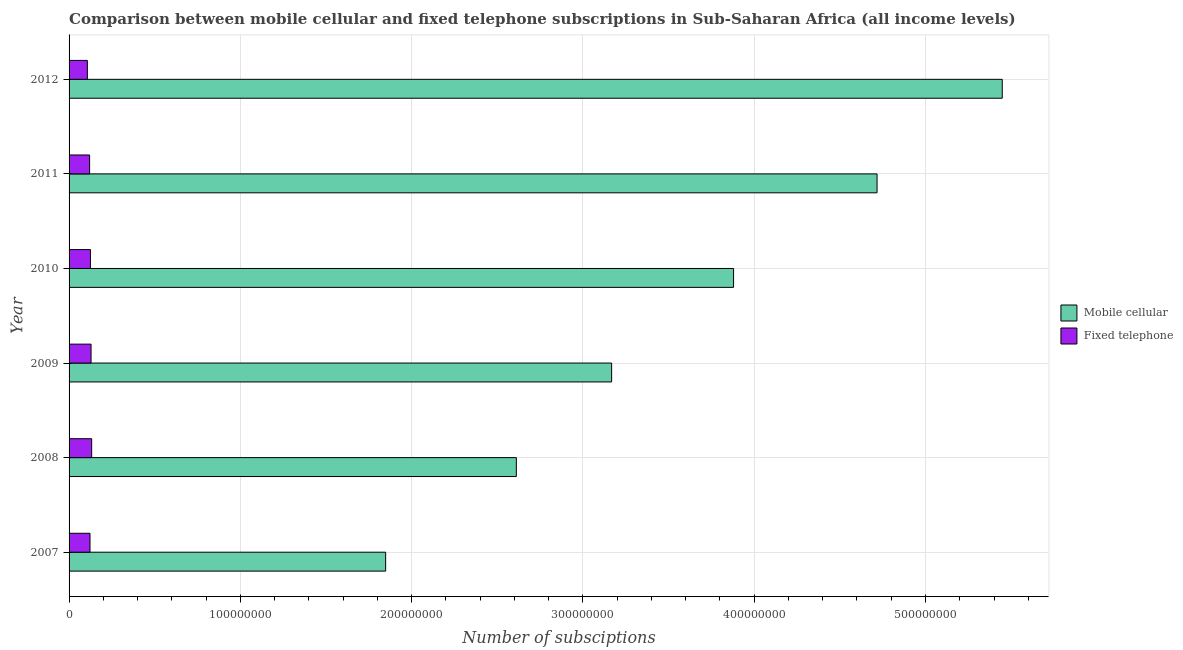How many different coloured bars are there?
Your response must be concise. 2. Are the number of bars per tick equal to the number of legend labels?
Provide a short and direct response. Yes. How many bars are there on the 1st tick from the bottom?
Your answer should be very brief. 2. What is the number of fixed telephone subscriptions in 2011?
Offer a terse response. 1.20e+07. Across all years, what is the maximum number of mobile cellular subscriptions?
Offer a very short reply. 5.45e+08. Across all years, what is the minimum number of fixed telephone subscriptions?
Your response must be concise. 1.07e+07. In which year was the number of fixed telephone subscriptions maximum?
Make the answer very short. 2008. What is the total number of fixed telephone subscriptions in the graph?
Give a very brief answer. 7.34e+07. What is the difference between the number of mobile cellular subscriptions in 2009 and that in 2011?
Your response must be concise. -1.55e+08. What is the difference between the number of fixed telephone subscriptions in 2011 and the number of mobile cellular subscriptions in 2012?
Give a very brief answer. -5.33e+08. What is the average number of mobile cellular subscriptions per year?
Make the answer very short. 3.61e+08. In the year 2010, what is the difference between the number of fixed telephone subscriptions and number of mobile cellular subscriptions?
Keep it short and to the point. -3.75e+08. In how many years, is the number of fixed telephone subscriptions greater than 220000000 ?
Offer a terse response. 0. What is the ratio of the number of fixed telephone subscriptions in 2007 to that in 2008?
Your response must be concise. 0.93. Is the number of mobile cellular subscriptions in 2007 less than that in 2008?
Provide a short and direct response. Yes. Is the difference between the number of mobile cellular subscriptions in 2007 and 2012 greater than the difference between the number of fixed telephone subscriptions in 2007 and 2012?
Keep it short and to the point. No. What is the difference between the highest and the second highest number of fixed telephone subscriptions?
Provide a succinct answer. 3.62e+05. What is the difference between the highest and the lowest number of mobile cellular subscriptions?
Your answer should be very brief. 3.60e+08. In how many years, is the number of fixed telephone subscriptions greater than the average number of fixed telephone subscriptions taken over all years?
Give a very brief answer. 3. Is the sum of the number of mobile cellular subscriptions in 2007 and 2009 greater than the maximum number of fixed telephone subscriptions across all years?
Keep it short and to the point. Yes. What does the 2nd bar from the top in 2009 represents?
Your answer should be compact. Mobile cellular. What does the 1st bar from the bottom in 2010 represents?
Your answer should be very brief. Mobile cellular. How many years are there in the graph?
Offer a terse response. 6. Does the graph contain grids?
Keep it short and to the point. Yes. How many legend labels are there?
Your answer should be compact. 2. What is the title of the graph?
Offer a very short reply. Comparison between mobile cellular and fixed telephone subscriptions in Sub-Saharan Africa (all income levels). What is the label or title of the X-axis?
Provide a succinct answer. Number of subsciptions. What is the label or title of the Y-axis?
Offer a terse response. Year. What is the Number of subsciptions in Mobile cellular in 2007?
Offer a very short reply. 1.85e+08. What is the Number of subsciptions in Fixed telephone in 2007?
Make the answer very short. 1.22e+07. What is the Number of subsciptions in Mobile cellular in 2008?
Provide a short and direct response. 2.61e+08. What is the Number of subsciptions in Fixed telephone in 2008?
Your response must be concise. 1.32e+07. What is the Number of subsciptions of Mobile cellular in 2009?
Make the answer very short. 3.17e+08. What is the Number of subsciptions of Fixed telephone in 2009?
Offer a terse response. 1.28e+07. What is the Number of subsciptions of Mobile cellular in 2010?
Keep it short and to the point. 3.88e+08. What is the Number of subsciptions of Fixed telephone in 2010?
Ensure brevity in your answer.  1.25e+07. What is the Number of subsciptions of Mobile cellular in 2011?
Ensure brevity in your answer.  4.72e+08. What is the Number of subsciptions in Fixed telephone in 2011?
Provide a short and direct response. 1.20e+07. What is the Number of subsciptions in Mobile cellular in 2012?
Your response must be concise. 5.45e+08. What is the Number of subsciptions in Fixed telephone in 2012?
Your answer should be compact. 1.07e+07. Across all years, what is the maximum Number of subsciptions in Mobile cellular?
Your response must be concise. 5.45e+08. Across all years, what is the maximum Number of subsciptions of Fixed telephone?
Ensure brevity in your answer.  1.32e+07. Across all years, what is the minimum Number of subsciptions of Mobile cellular?
Provide a short and direct response. 1.85e+08. Across all years, what is the minimum Number of subsciptions in Fixed telephone?
Make the answer very short. 1.07e+07. What is the total Number of subsciptions in Mobile cellular in the graph?
Keep it short and to the point. 2.17e+09. What is the total Number of subsciptions in Fixed telephone in the graph?
Offer a very short reply. 7.34e+07. What is the difference between the Number of subsciptions in Mobile cellular in 2007 and that in 2008?
Offer a terse response. -7.63e+07. What is the difference between the Number of subsciptions of Fixed telephone in 2007 and that in 2008?
Provide a succinct answer. -9.74e+05. What is the difference between the Number of subsciptions in Mobile cellular in 2007 and that in 2009?
Offer a very short reply. -1.32e+08. What is the difference between the Number of subsciptions in Fixed telephone in 2007 and that in 2009?
Your response must be concise. -6.12e+05. What is the difference between the Number of subsciptions in Mobile cellular in 2007 and that in 2010?
Ensure brevity in your answer.  -2.03e+08. What is the difference between the Number of subsciptions in Fixed telephone in 2007 and that in 2010?
Keep it short and to the point. -2.62e+05. What is the difference between the Number of subsciptions in Mobile cellular in 2007 and that in 2011?
Provide a succinct answer. -2.87e+08. What is the difference between the Number of subsciptions in Fixed telephone in 2007 and that in 2011?
Ensure brevity in your answer.  2.26e+05. What is the difference between the Number of subsciptions in Mobile cellular in 2007 and that in 2012?
Ensure brevity in your answer.  -3.60e+08. What is the difference between the Number of subsciptions of Fixed telephone in 2007 and that in 2012?
Provide a short and direct response. 1.54e+06. What is the difference between the Number of subsciptions of Mobile cellular in 2008 and that in 2009?
Provide a short and direct response. -5.56e+07. What is the difference between the Number of subsciptions in Fixed telephone in 2008 and that in 2009?
Keep it short and to the point. 3.62e+05. What is the difference between the Number of subsciptions of Mobile cellular in 2008 and that in 2010?
Your response must be concise. -1.27e+08. What is the difference between the Number of subsciptions of Fixed telephone in 2008 and that in 2010?
Make the answer very short. 7.12e+05. What is the difference between the Number of subsciptions in Mobile cellular in 2008 and that in 2011?
Offer a very short reply. -2.11e+08. What is the difference between the Number of subsciptions of Fixed telephone in 2008 and that in 2011?
Provide a succinct answer. 1.20e+06. What is the difference between the Number of subsciptions in Mobile cellular in 2008 and that in 2012?
Ensure brevity in your answer.  -2.84e+08. What is the difference between the Number of subsciptions of Fixed telephone in 2008 and that in 2012?
Offer a very short reply. 2.51e+06. What is the difference between the Number of subsciptions of Mobile cellular in 2009 and that in 2010?
Make the answer very short. -7.12e+07. What is the difference between the Number of subsciptions of Fixed telephone in 2009 and that in 2010?
Your answer should be very brief. 3.50e+05. What is the difference between the Number of subsciptions of Mobile cellular in 2009 and that in 2011?
Provide a succinct answer. -1.55e+08. What is the difference between the Number of subsciptions of Fixed telephone in 2009 and that in 2011?
Give a very brief answer. 8.38e+05. What is the difference between the Number of subsciptions of Mobile cellular in 2009 and that in 2012?
Ensure brevity in your answer.  -2.28e+08. What is the difference between the Number of subsciptions in Fixed telephone in 2009 and that in 2012?
Your response must be concise. 2.15e+06. What is the difference between the Number of subsciptions in Mobile cellular in 2010 and that in 2011?
Provide a short and direct response. -8.38e+07. What is the difference between the Number of subsciptions in Fixed telephone in 2010 and that in 2011?
Provide a short and direct response. 4.88e+05. What is the difference between the Number of subsciptions in Mobile cellular in 2010 and that in 2012?
Make the answer very short. -1.57e+08. What is the difference between the Number of subsciptions in Fixed telephone in 2010 and that in 2012?
Your answer should be very brief. 1.80e+06. What is the difference between the Number of subsciptions of Mobile cellular in 2011 and that in 2012?
Offer a terse response. -7.31e+07. What is the difference between the Number of subsciptions in Fixed telephone in 2011 and that in 2012?
Keep it short and to the point. 1.31e+06. What is the difference between the Number of subsciptions in Mobile cellular in 2007 and the Number of subsciptions in Fixed telephone in 2008?
Keep it short and to the point. 1.72e+08. What is the difference between the Number of subsciptions in Mobile cellular in 2007 and the Number of subsciptions in Fixed telephone in 2009?
Provide a succinct answer. 1.72e+08. What is the difference between the Number of subsciptions of Mobile cellular in 2007 and the Number of subsciptions of Fixed telephone in 2010?
Offer a terse response. 1.72e+08. What is the difference between the Number of subsciptions in Mobile cellular in 2007 and the Number of subsciptions in Fixed telephone in 2011?
Offer a very short reply. 1.73e+08. What is the difference between the Number of subsciptions in Mobile cellular in 2007 and the Number of subsciptions in Fixed telephone in 2012?
Ensure brevity in your answer.  1.74e+08. What is the difference between the Number of subsciptions of Mobile cellular in 2008 and the Number of subsciptions of Fixed telephone in 2009?
Make the answer very short. 2.48e+08. What is the difference between the Number of subsciptions in Mobile cellular in 2008 and the Number of subsciptions in Fixed telephone in 2010?
Offer a terse response. 2.49e+08. What is the difference between the Number of subsciptions of Mobile cellular in 2008 and the Number of subsciptions of Fixed telephone in 2011?
Provide a succinct answer. 2.49e+08. What is the difference between the Number of subsciptions in Mobile cellular in 2008 and the Number of subsciptions in Fixed telephone in 2012?
Keep it short and to the point. 2.50e+08. What is the difference between the Number of subsciptions in Mobile cellular in 2009 and the Number of subsciptions in Fixed telephone in 2010?
Provide a succinct answer. 3.04e+08. What is the difference between the Number of subsciptions in Mobile cellular in 2009 and the Number of subsciptions in Fixed telephone in 2011?
Give a very brief answer. 3.05e+08. What is the difference between the Number of subsciptions in Mobile cellular in 2009 and the Number of subsciptions in Fixed telephone in 2012?
Provide a short and direct response. 3.06e+08. What is the difference between the Number of subsciptions of Mobile cellular in 2010 and the Number of subsciptions of Fixed telephone in 2011?
Provide a short and direct response. 3.76e+08. What is the difference between the Number of subsciptions in Mobile cellular in 2010 and the Number of subsciptions in Fixed telephone in 2012?
Your answer should be very brief. 3.77e+08. What is the difference between the Number of subsciptions of Mobile cellular in 2011 and the Number of subsciptions of Fixed telephone in 2012?
Provide a short and direct response. 4.61e+08. What is the average Number of subsciptions in Mobile cellular per year?
Your answer should be very brief. 3.61e+08. What is the average Number of subsciptions in Fixed telephone per year?
Keep it short and to the point. 1.22e+07. In the year 2007, what is the difference between the Number of subsciptions of Mobile cellular and Number of subsciptions of Fixed telephone?
Your response must be concise. 1.73e+08. In the year 2008, what is the difference between the Number of subsciptions of Mobile cellular and Number of subsciptions of Fixed telephone?
Offer a terse response. 2.48e+08. In the year 2009, what is the difference between the Number of subsciptions of Mobile cellular and Number of subsciptions of Fixed telephone?
Give a very brief answer. 3.04e+08. In the year 2010, what is the difference between the Number of subsciptions in Mobile cellular and Number of subsciptions in Fixed telephone?
Give a very brief answer. 3.75e+08. In the year 2011, what is the difference between the Number of subsciptions of Mobile cellular and Number of subsciptions of Fixed telephone?
Provide a short and direct response. 4.60e+08. In the year 2012, what is the difference between the Number of subsciptions in Mobile cellular and Number of subsciptions in Fixed telephone?
Make the answer very short. 5.34e+08. What is the ratio of the Number of subsciptions of Mobile cellular in 2007 to that in 2008?
Provide a succinct answer. 0.71. What is the ratio of the Number of subsciptions in Fixed telephone in 2007 to that in 2008?
Ensure brevity in your answer.  0.93. What is the ratio of the Number of subsciptions in Mobile cellular in 2007 to that in 2009?
Provide a succinct answer. 0.58. What is the ratio of the Number of subsciptions in Fixed telephone in 2007 to that in 2009?
Offer a terse response. 0.95. What is the ratio of the Number of subsciptions in Mobile cellular in 2007 to that in 2010?
Your answer should be compact. 0.48. What is the ratio of the Number of subsciptions in Mobile cellular in 2007 to that in 2011?
Ensure brevity in your answer.  0.39. What is the ratio of the Number of subsciptions of Fixed telephone in 2007 to that in 2011?
Give a very brief answer. 1.02. What is the ratio of the Number of subsciptions in Mobile cellular in 2007 to that in 2012?
Offer a very short reply. 0.34. What is the ratio of the Number of subsciptions of Fixed telephone in 2007 to that in 2012?
Offer a terse response. 1.14. What is the ratio of the Number of subsciptions in Mobile cellular in 2008 to that in 2009?
Your answer should be compact. 0.82. What is the ratio of the Number of subsciptions of Fixed telephone in 2008 to that in 2009?
Keep it short and to the point. 1.03. What is the ratio of the Number of subsciptions in Mobile cellular in 2008 to that in 2010?
Provide a succinct answer. 0.67. What is the ratio of the Number of subsciptions in Fixed telephone in 2008 to that in 2010?
Offer a very short reply. 1.06. What is the ratio of the Number of subsciptions of Mobile cellular in 2008 to that in 2011?
Your answer should be very brief. 0.55. What is the ratio of the Number of subsciptions of Fixed telephone in 2008 to that in 2011?
Provide a short and direct response. 1.1. What is the ratio of the Number of subsciptions in Mobile cellular in 2008 to that in 2012?
Your answer should be very brief. 0.48. What is the ratio of the Number of subsciptions in Fixed telephone in 2008 to that in 2012?
Your answer should be very brief. 1.24. What is the ratio of the Number of subsciptions in Mobile cellular in 2009 to that in 2010?
Make the answer very short. 0.82. What is the ratio of the Number of subsciptions of Fixed telephone in 2009 to that in 2010?
Provide a short and direct response. 1.03. What is the ratio of the Number of subsciptions in Mobile cellular in 2009 to that in 2011?
Provide a short and direct response. 0.67. What is the ratio of the Number of subsciptions in Fixed telephone in 2009 to that in 2011?
Ensure brevity in your answer.  1.07. What is the ratio of the Number of subsciptions in Mobile cellular in 2009 to that in 2012?
Offer a very short reply. 0.58. What is the ratio of the Number of subsciptions in Fixed telephone in 2009 to that in 2012?
Keep it short and to the point. 1.2. What is the ratio of the Number of subsciptions of Mobile cellular in 2010 to that in 2011?
Your answer should be very brief. 0.82. What is the ratio of the Number of subsciptions of Fixed telephone in 2010 to that in 2011?
Keep it short and to the point. 1.04. What is the ratio of the Number of subsciptions of Mobile cellular in 2010 to that in 2012?
Keep it short and to the point. 0.71. What is the ratio of the Number of subsciptions in Fixed telephone in 2010 to that in 2012?
Make the answer very short. 1.17. What is the ratio of the Number of subsciptions of Mobile cellular in 2011 to that in 2012?
Provide a short and direct response. 0.87. What is the ratio of the Number of subsciptions in Fixed telephone in 2011 to that in 2012?
Your answer should be very brief. 1.12. What is the difference between the highest and the second highest Number of subsciptions in Mobile cellular?
Make the answer very short. 7.31e+07. What is the difference between the highest and the second highest Number of subsciptions in Fixed telephone?
Ensure brevity in your answer.  3.62e+05. What is the difference between the highest and the lowest Number of subsciptions in Mobile cellular?
Your response must be concise. 3.60e+08. What is the difference between the highest and the lowest Number of subsciptions in Fixed telephone?
Provide a short and direct response. 2.51e+06. 